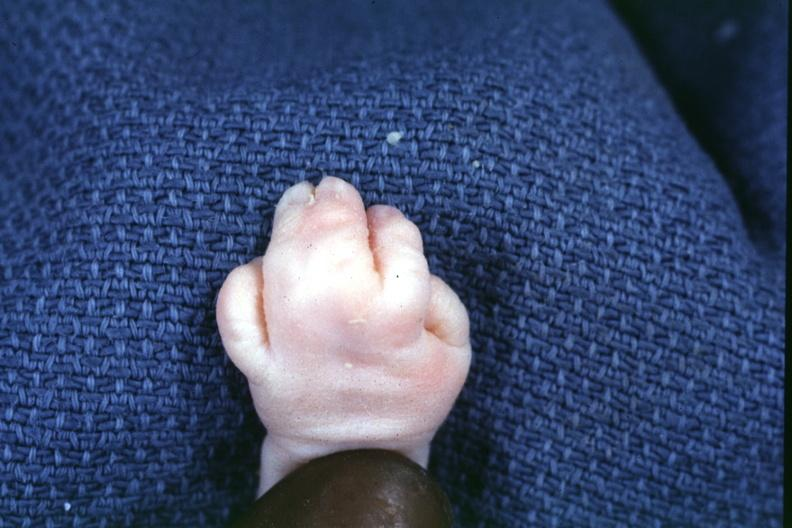re extremities present?
Answer the question using a single word or phrase. Yes 